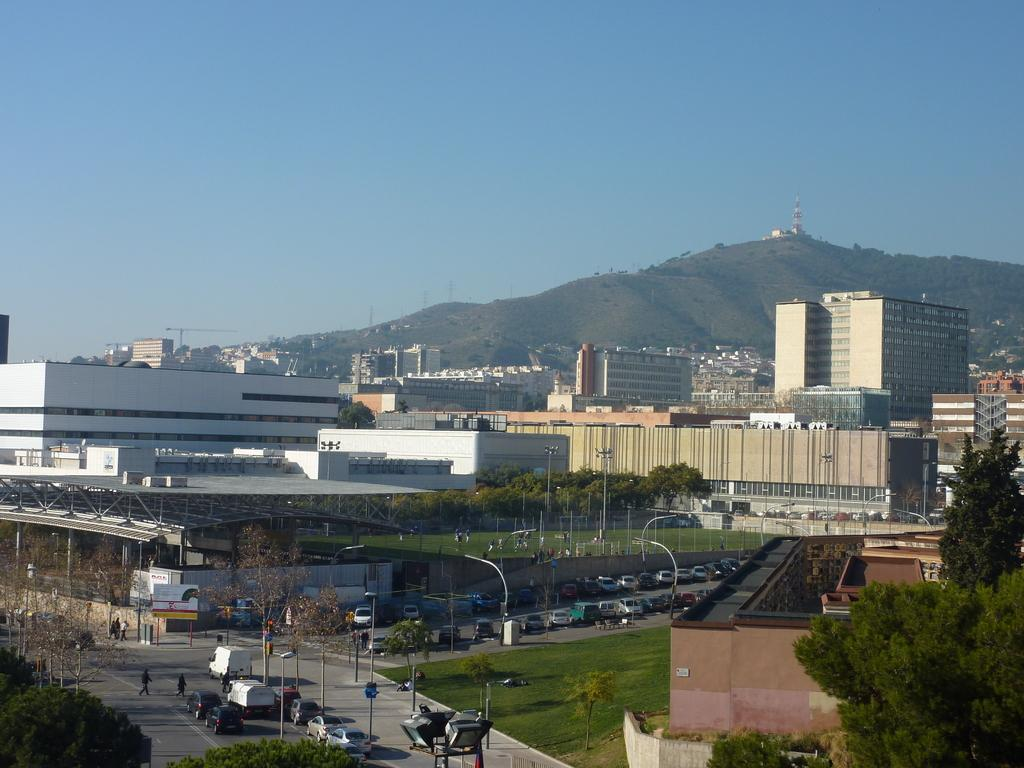What type of structures can be seen in the image? There are buildings in the image. What natural elements are present in the image? There are trees and mountains in the image. What man-made objects can be seen in the image? There are vehicles, poles, and lights in the image. What architectural features are visible in the buildings? There are windows in the buildings. Who or what is present in the image? There are people in the image. What can be seen in the background of the image? The sky is visible in the background of the image. What type of rod is being used to burn the trees in the image? There is no rod or burning of trees present in the image. How many lights are being used to illuminate the mountains in the image? There are no lights specifically illuminating the mountains in the image. 